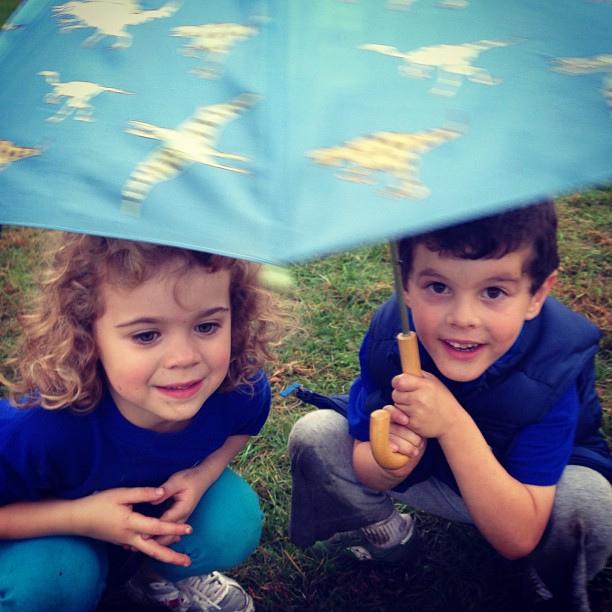What are they holding?
Quick response, please. Umbrella. What animal print is on the umbrella?
Give a very brief answer. Dinosaur. What color shirts are the children wearing?
Be succinct. Blue. 